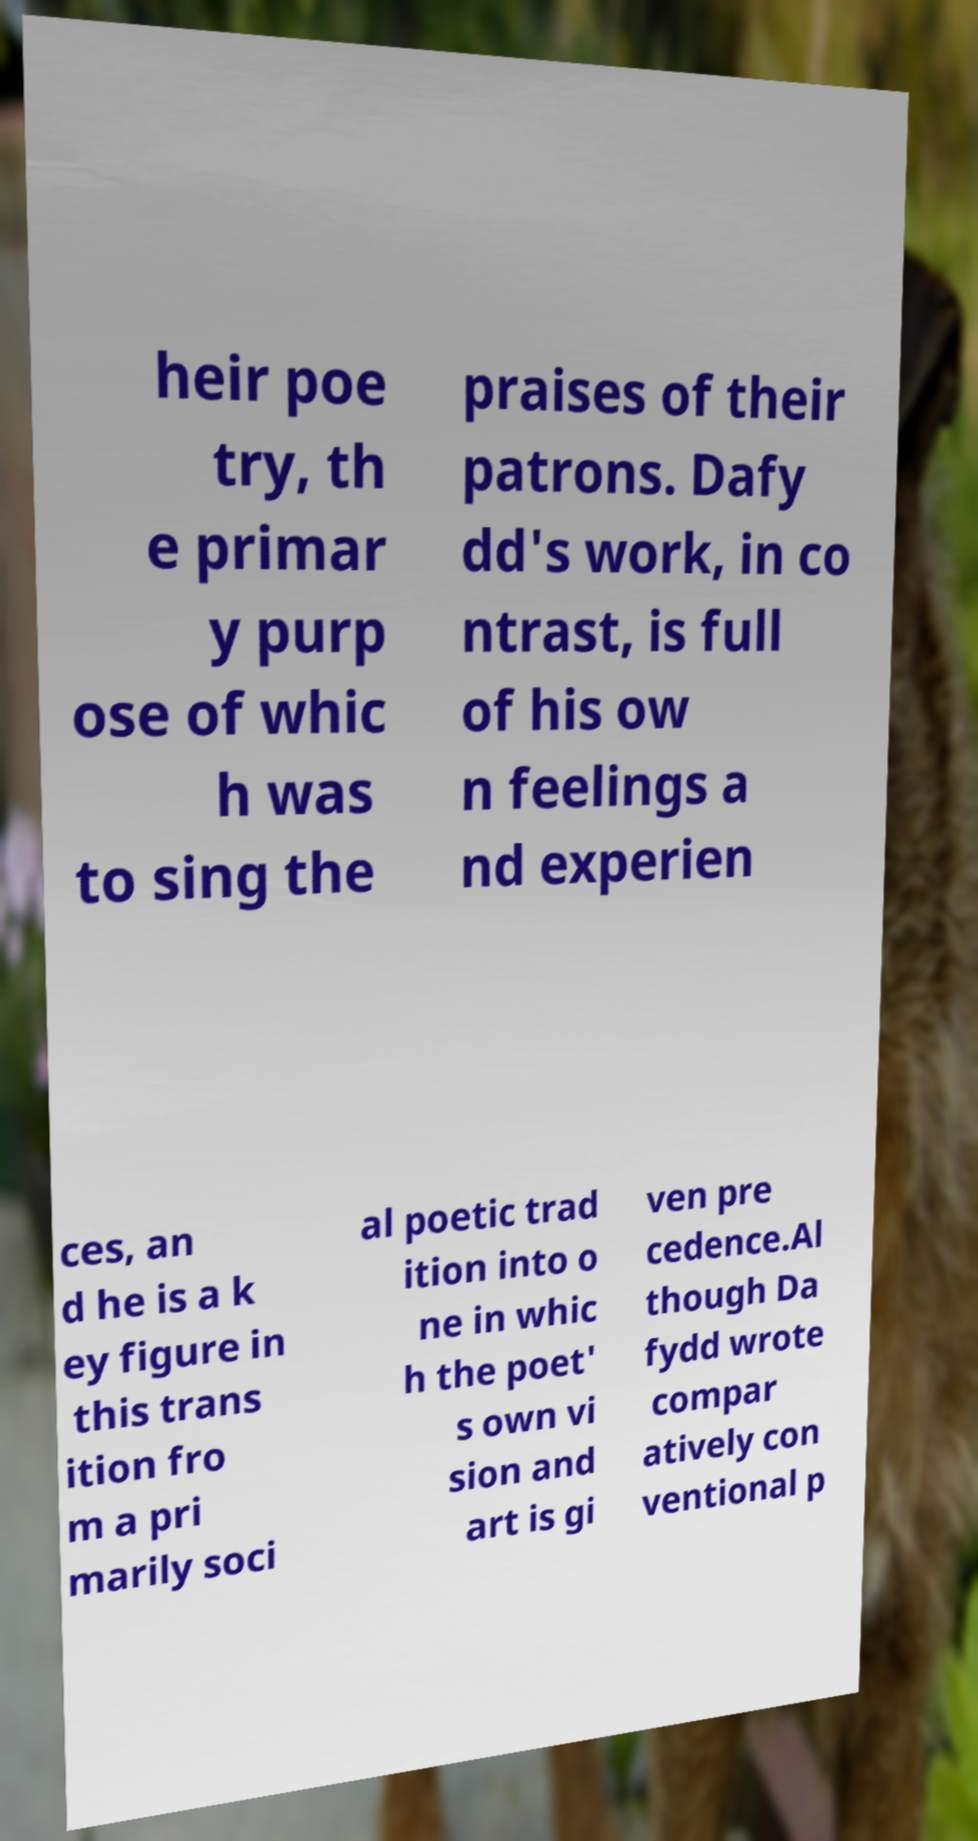Could you extract and type out the text from this image? heir poe try, th e primar y purp ose of whic h was to sing the praises of their patrons. Dafy dd's work, in co ntrast, is full of his ow n feelings a nd experien ces, an d he is a k ey figure in this trans ition fro m a pri marily soci al poetic trad ition into o ne in whic h the poet' s own vi sion and art is gi ven pre cedence.Al though Da fydd wrote compar atively con ventional p 